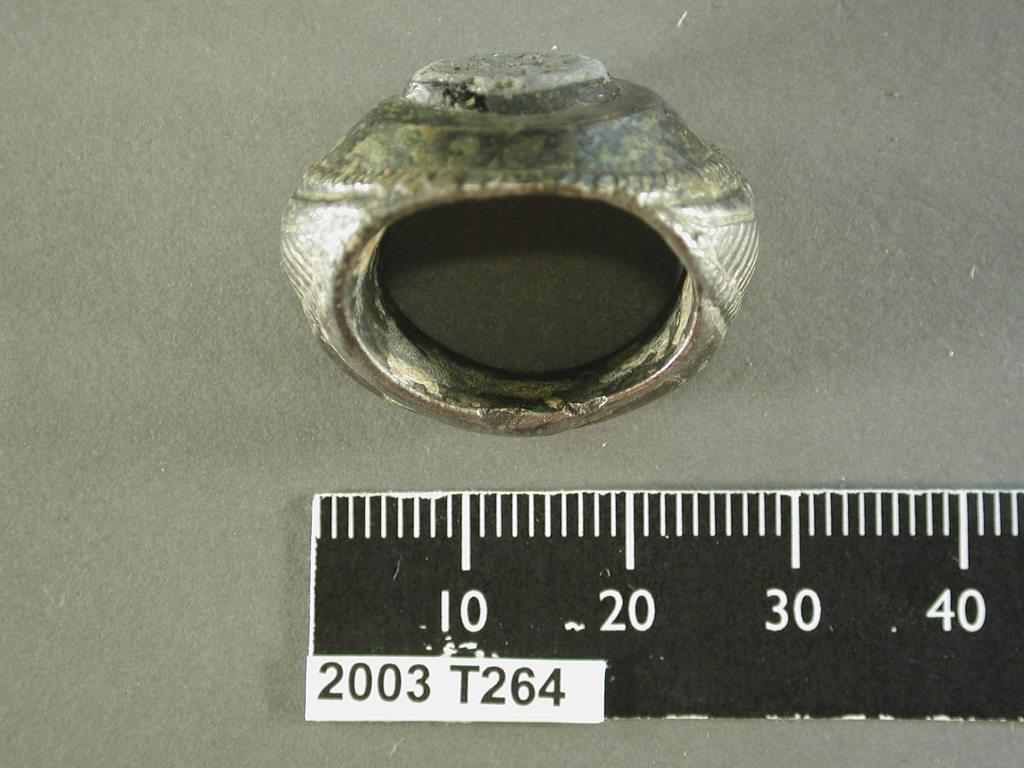<image>
Provide a brief description of the given image. Black ruler that goes up to 40 measuring a ring. 